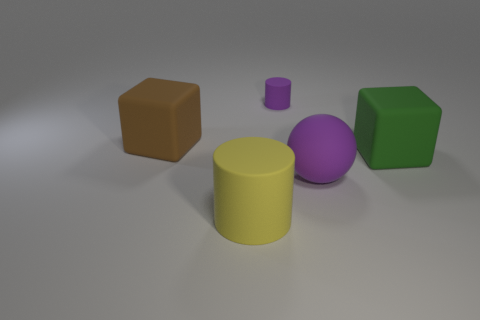Does the sphere have the same color as the small object?
Keep it short and to the point. Yes. Is there any other thing that is the same size as the purple matte cylinder?
Offer a very short reply. No. What number of metal objects are either small objects or tiny red cylinders?
Offer a terse response. 0. There is a sphere that is the same color as the small rubber thing; what is it made of?
Provide a short and direct response. Rubber. Are there fewer brown rubber objects that are to the right of the large green block than purple spheres on the right side of the tiny purple object?
Your answer should be very brief. Yes. How many things are either green matte objects or objects on the left side of the tiny rubber cylinder?
Offer a terse response. 3. There is a sphere that is the same size as the green matte cube; what material is it?
Offer a terse response. Rubber. Is the tiny purple object made of the same material as the big brown object?
Offer a terse response. Yes. What color is the object that is in front of the big brown matte block and on the left side of the tiny cylinder?
Ensure brevity in your answer.  Yellow. There is a matte cylinder behind the big brown rubber thing; is it the same color as the big matte ball?
Ensure brevity in your answer.  Yes. 